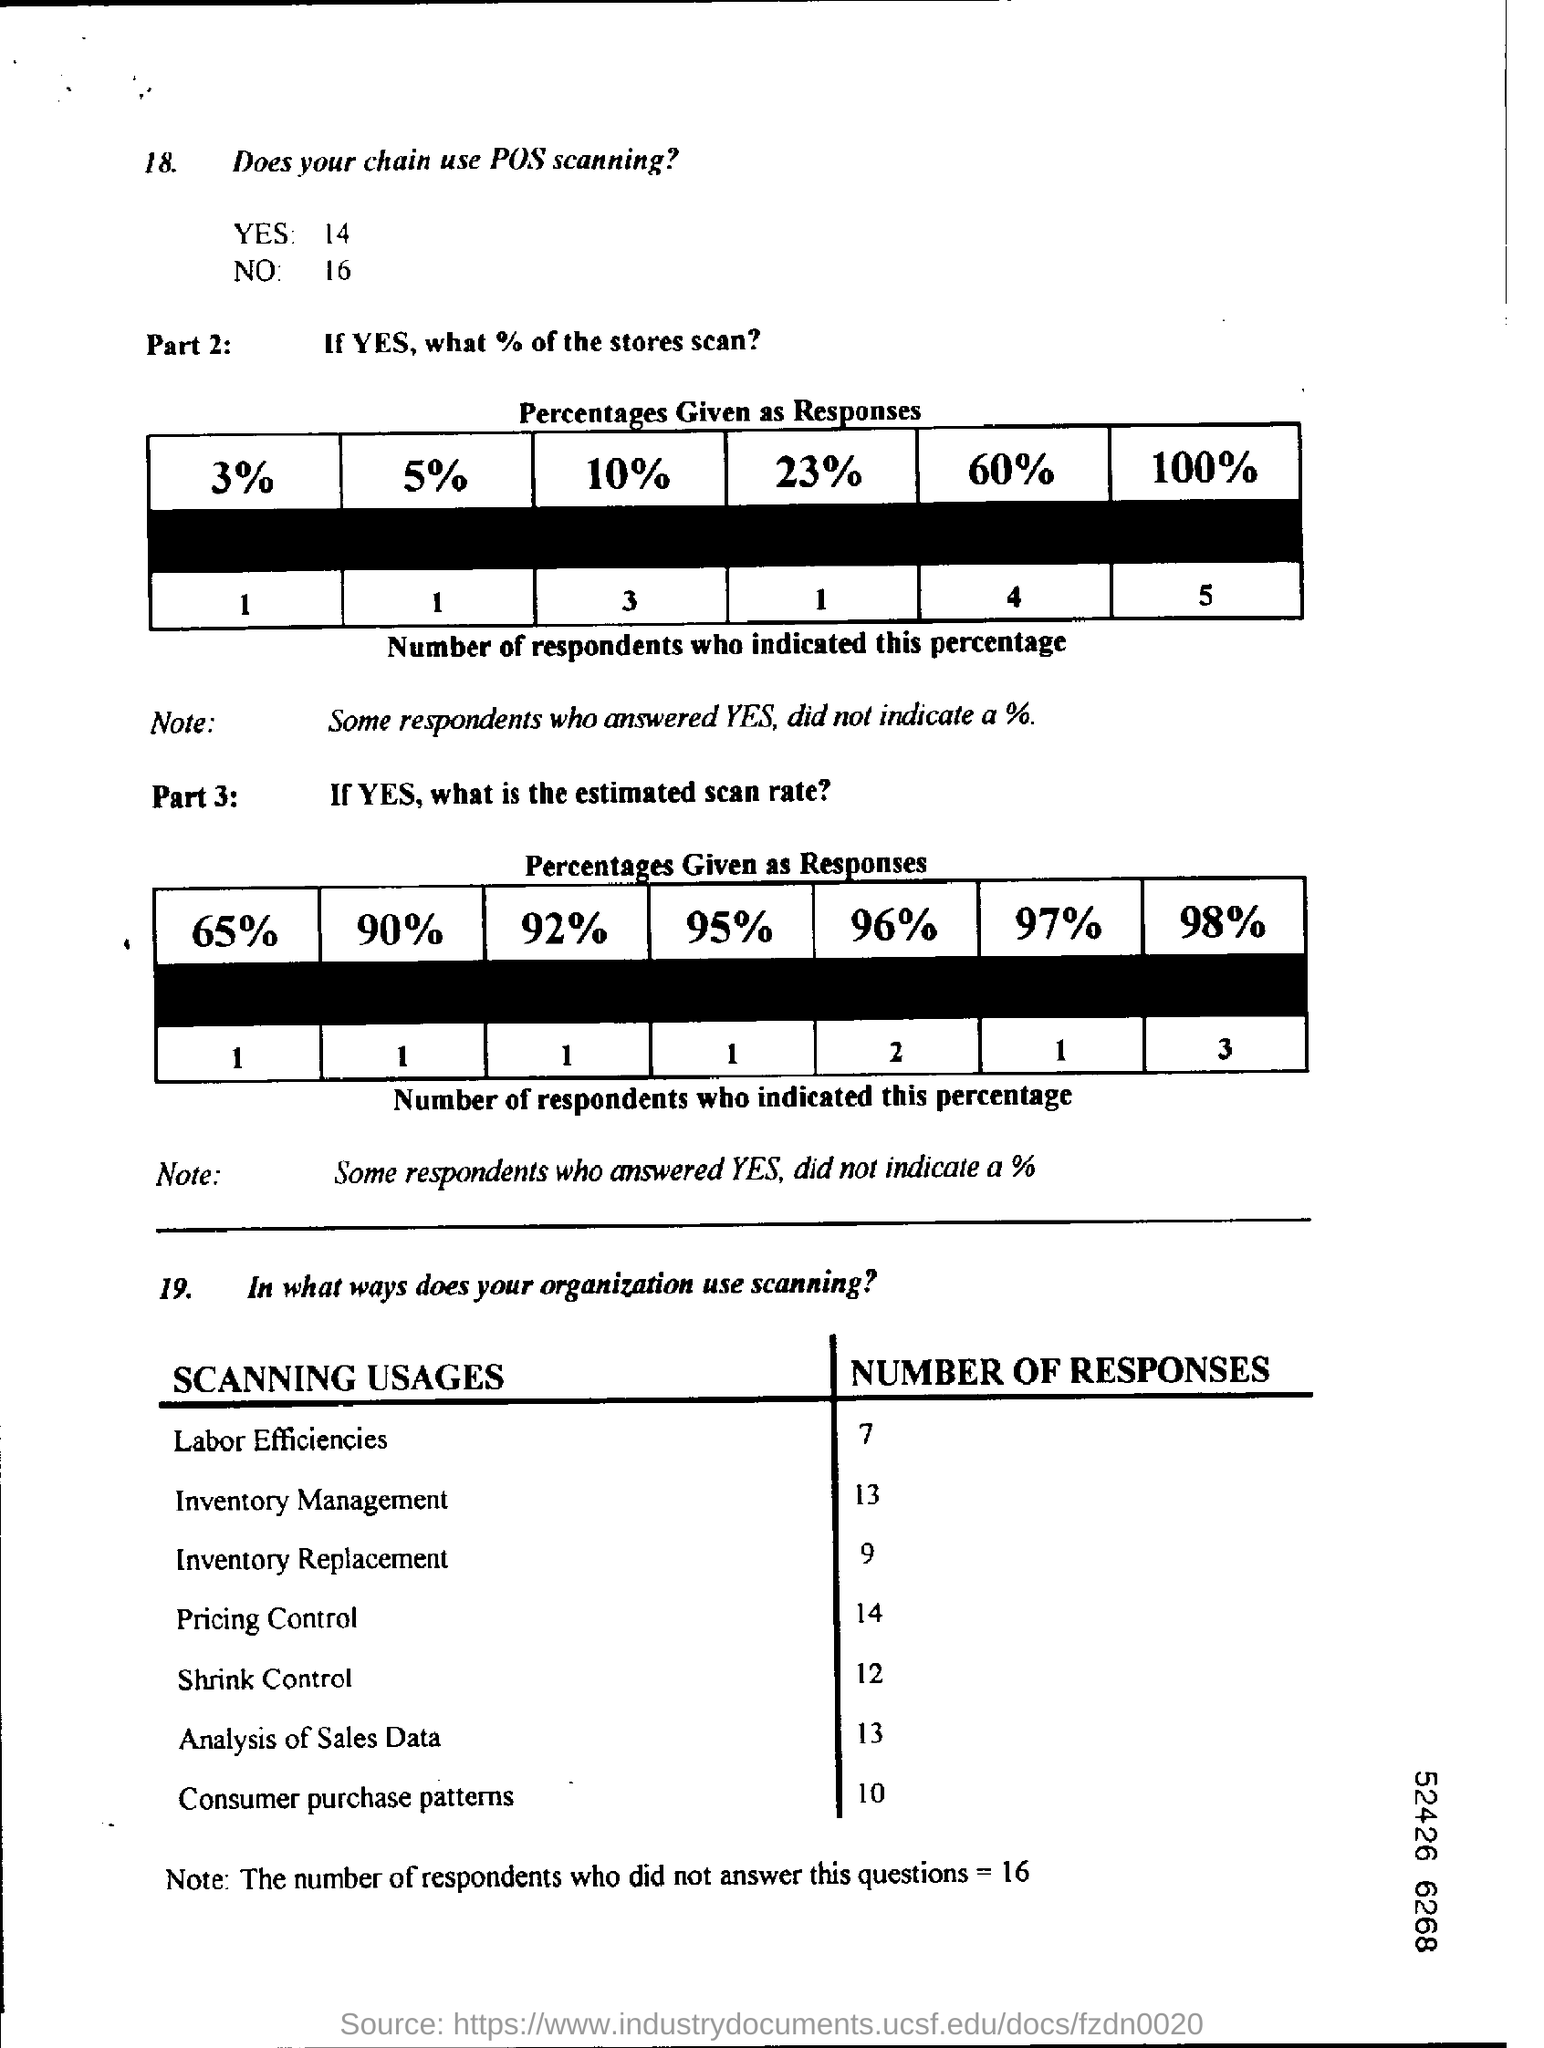Number of responses in Labor Efficiencies ?
Your answer should be compact. 7. Number of responses in Pricing Control ?
Offer a terse response. 14. Number of responses in Inventory Management ?
Keep it short and to the point. 13. Number of responses in Inventory Replacement ?
Your response must be concise. 9. 